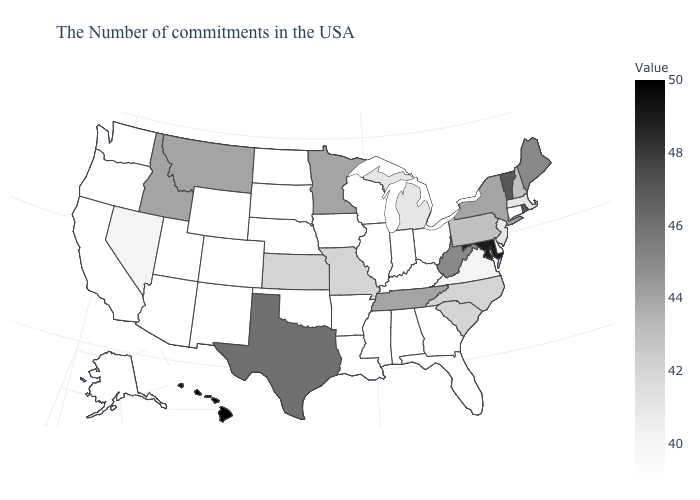Among the states that border North Carolina , which have the lowest value?
Short answer required. Georgia. Does Kansas have the lowest value in the MidWest?
Write a very short answer. No. Among the states that border Connecticut , which have the lowest value?
Write a very short answer. Massachusetts. Does Louisiana have the highest value in the USA?
Be succinct. No. Which states have the lowest value in the USA?
Give a very brief answer. Connecticut, Delaware, Ohio, Florida, Georgia, Kentucky, Indiana, Alabama, Wisconsin, Illinois, Mississippi, Louisiana, Arkansas, Iowa, Nebraska, Oklahoma, South Dakota, North Dakota, Wyoming, Colorado, New Mexico, Utah, Arizona, California, Washington, Oregon, Alaska. 